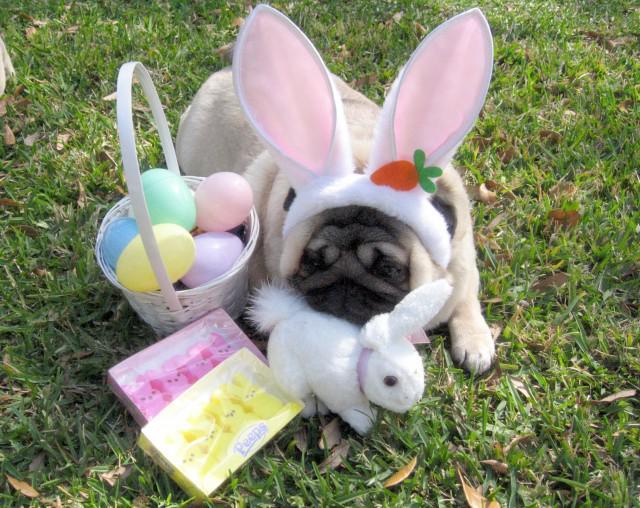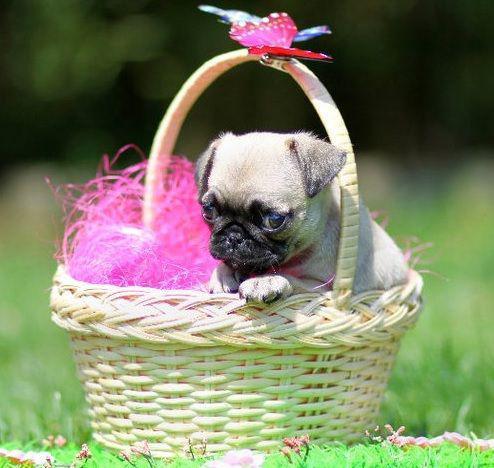The first image is the image on the left, the second image is the image on the right. For the images shown, is this caption "there is a pug  wearing costume bunny ears laying next to a stuffed bunny toy" true? Answer yes or no. Yes. The first image is the image on the left, the second image is the image on the right. Analyze the images presented: Is the assertion "The left image shows a pug wearing bunny ears by a stuffed toy with bunny ears." valid? Answer yes or no. Yes. 